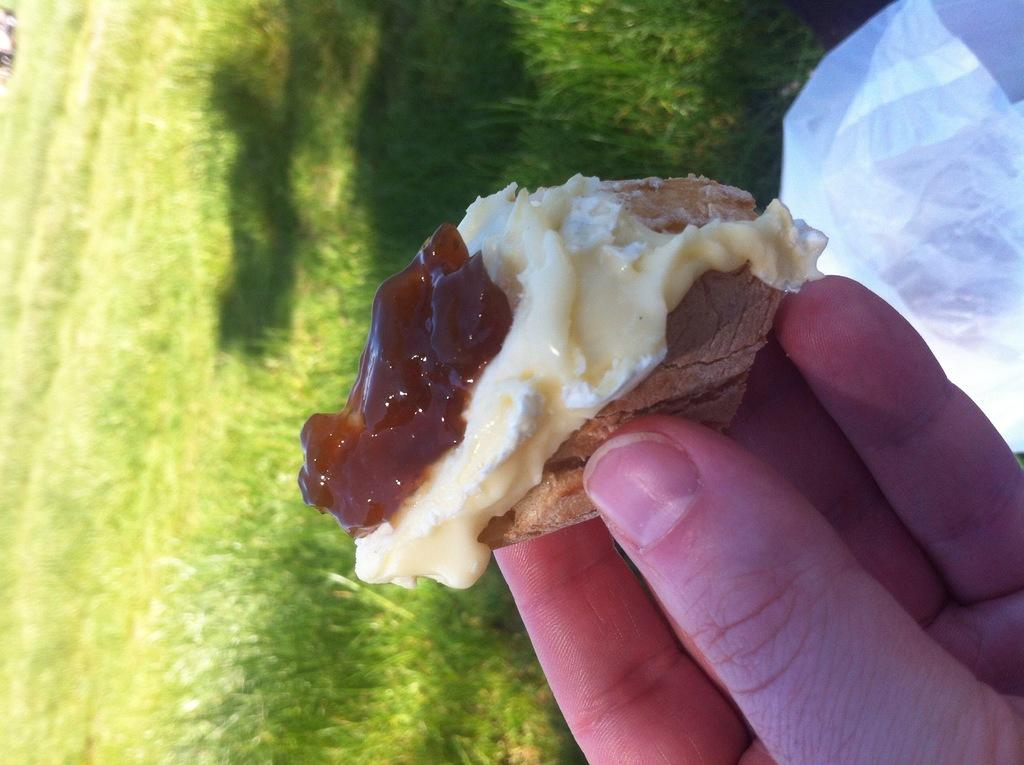What can be seen in the image related to a person's body part? There is a person's hand in the image. What is the hand holding? The hand is holding a food item. What type of environment is visible in the background of the image? There is grass visible in the background of the image. Can you hear the sound of the hall in the image? There is no sound or hall mentioned in the image; it only contains a person's hand holding a food item and a grassy background. 